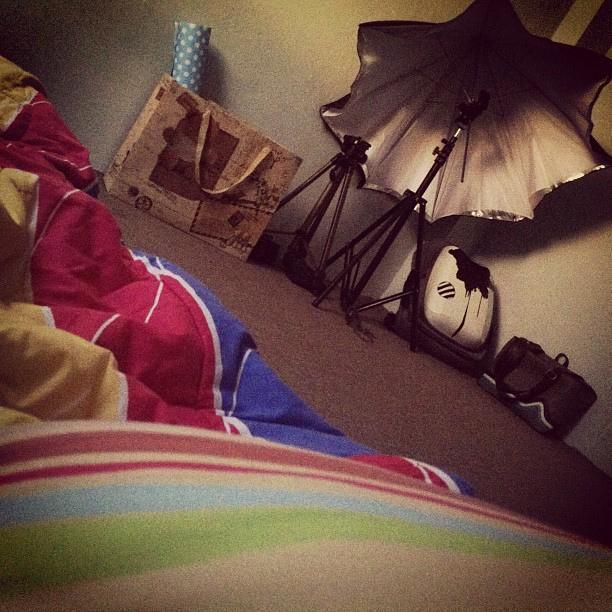How many objects are shown in the picture?
Give a very brief answer. 6. How many handbags are in the picture?
Give a very brief answer. 2. How many people are playing?
Give a very brief answer. 0. 